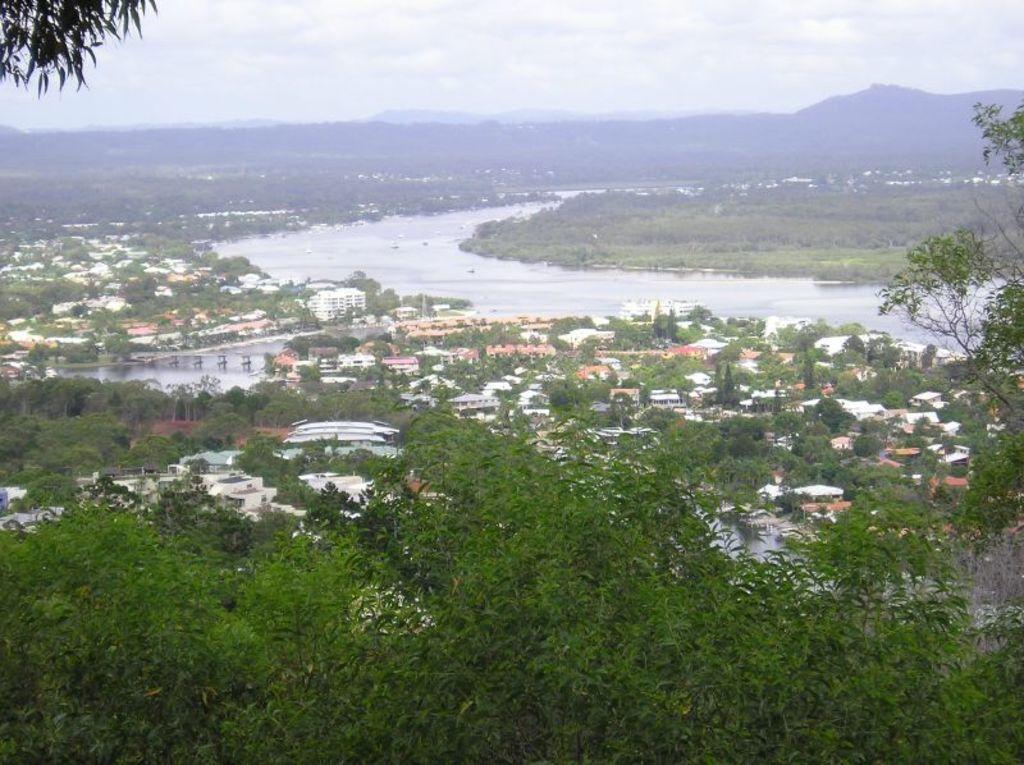How would you summarize this image in a sentence or two? In this picture we can see trees, buildings and water. In the background of the image we can see hills and sky with clouds. 